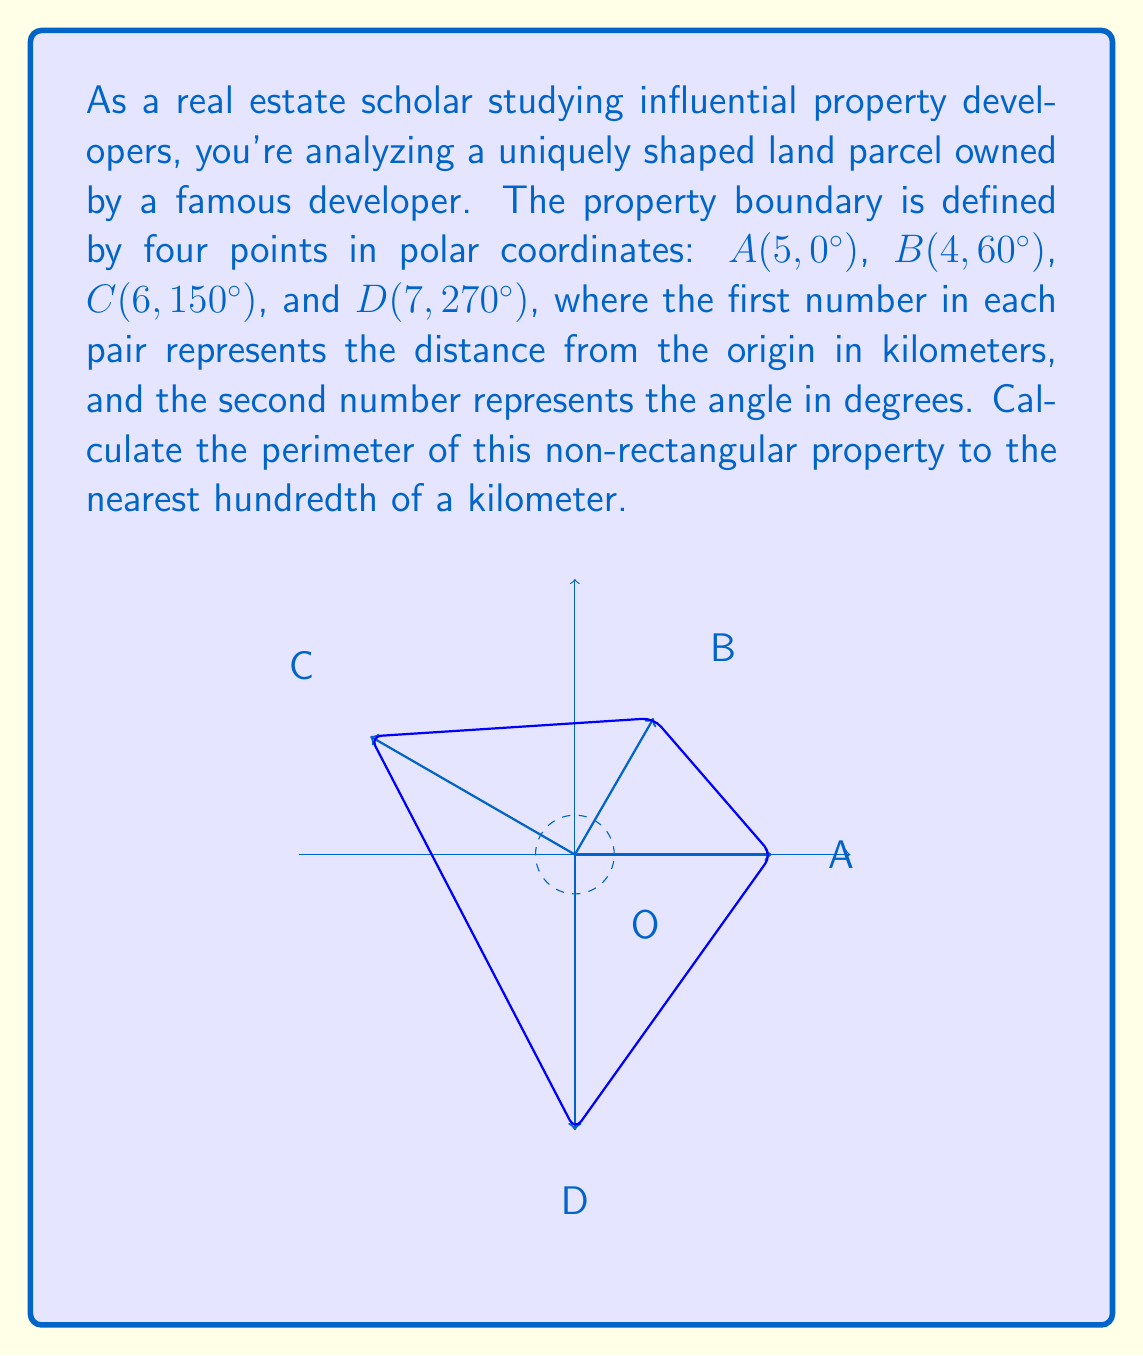What is the answer to this math problem? To solve this problem, we need to calculate the distance between each pair of consecutive points and sum these distances. We'll use the law of cosines to find the length of each side.

The law of cosines states that for a triangle with sides a, b, and c, and an angle C opposite the side c:

$$ c^2 = a^2 + b^2 - 2ab \cos(C) $$

Let's calculate each side:

1) Side AB:
   $$ AB^2 = 5^2 + 4^2 - 2(5)(4)\cos(60°) $$
   $$ AB^2 = 25 + 16 - 40(0.5) = 21 $$
   $$ AB = \sqrt{21} \approx 4.58 \text{ km} $$

2) Side BC:
   $$ BC^2 = 4^2 + 6^2 - 2(4)(6)\cos(150° - 60°) $$
   $$ BC^2 = 16 + 36 - 48\cos(90°) = 52 $$
   $$ BC = \sqrt{52} \approx 7.21 \text{ km} $$

3) Side CD:
   $$ CD^2 = 6^2 + 7^2 - 2(6)(7)\cos(270° - 150°) $$
   $$ CD^2 = 36 + 49 - 84\cos(120°) = 127 $$
   $$ CD = \sqrt{127} \approx 11.27 \text{ km} $$

4) Side DA:
   $$ DA^2 = 7^2 + 5^2 - 2(7)(5)\cos(360° - 270°) $$
   $$ DA^2 = 49 + 25 - 70\cos(90°) = 74 $$
   $$ DA = \sqrt{74} \approx 8.60 \text{ km} $$

The perimeter is the sum of these four sides:
$$ \text{Perimeter} = AB + BC + CD + DA $$
$$ \text{Perimeter} \approx 4.58 + 7.21 + 11.27 + 8.60 = 31.66 \text{ km} $$

Rounded to the nearest hundredth, the perimeter is 31.66 km.
Answer: 31.66 km 